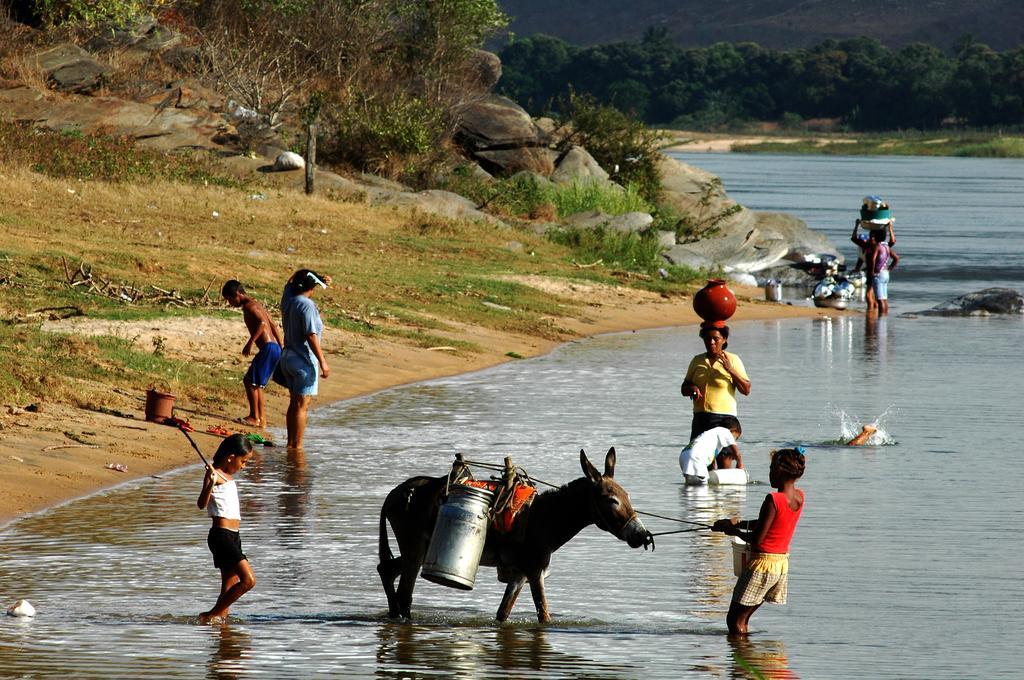Please provide a concise description of this image. In this image we can see a few people in the water and also we can see a donkey, there are some cans, buckets, trees, grass, rocks and some other objects, in the background, we can see the mountains. 